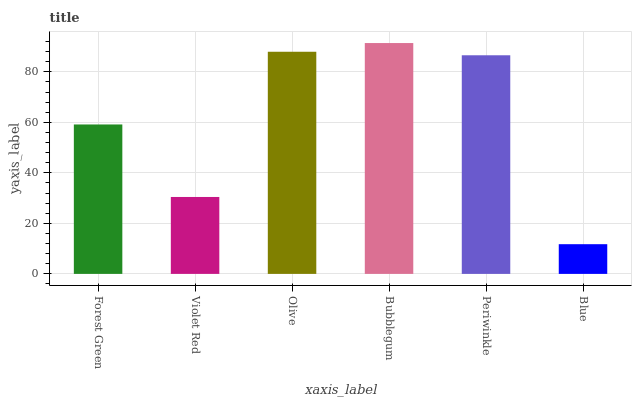Is Blue the minimum?
Answer yes or no. Yes. Is Bubblegum the maximum?
Answer yes or no. Yes. Is Violet Red the minimum?
Answer yes or no. No. Is Violet Red the maximum?
Answer yes or no. No. Is Forest Green greater than Violet Red?
Answer yes or no. Yes. Is Violet Red less than Forest Green?
Answer yes or no. Yes. Is Violet Red greater than Forest Green?
Answer yes or no. No. Is Forest Green less than Violet Red?
Answer yes or no. No. Is Periwinkle the high median?
Answer yes or no. Yes. Is Forest Green the low median?
Answer yes or no. Yes. Is Forest Green the high median?
Answer yes or no. No. Is Blue the low median?
Answer yes or no. No. 